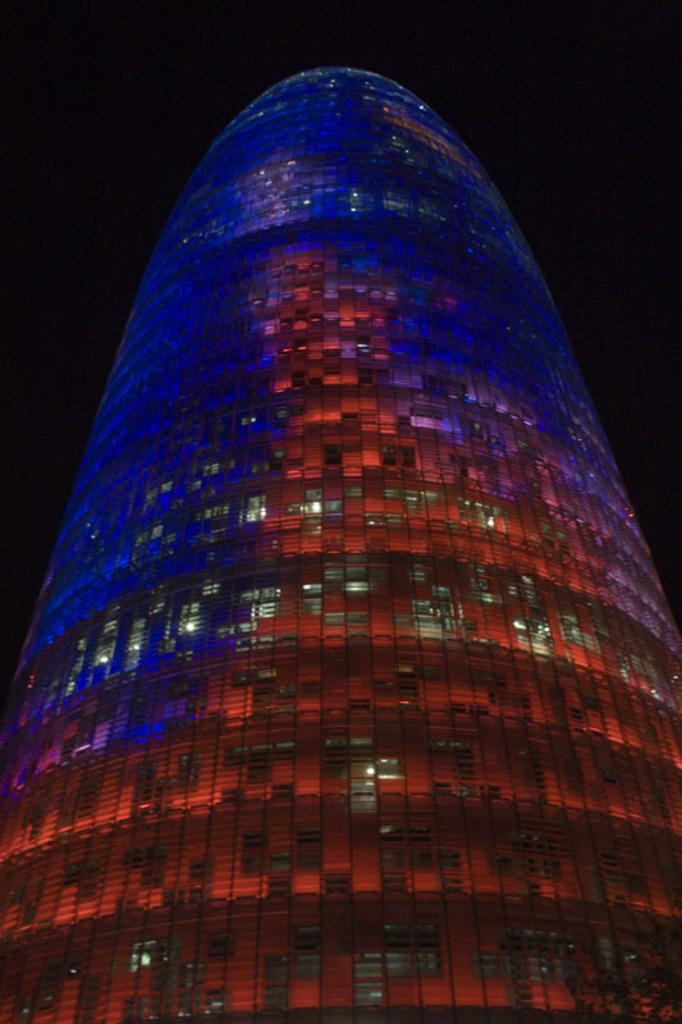What is the main subject in the center of the image? There is a building in the center of the image. What type of stamp can be seen on the building's facade in the image? There is no stamp visible on the building's facade in the image. 